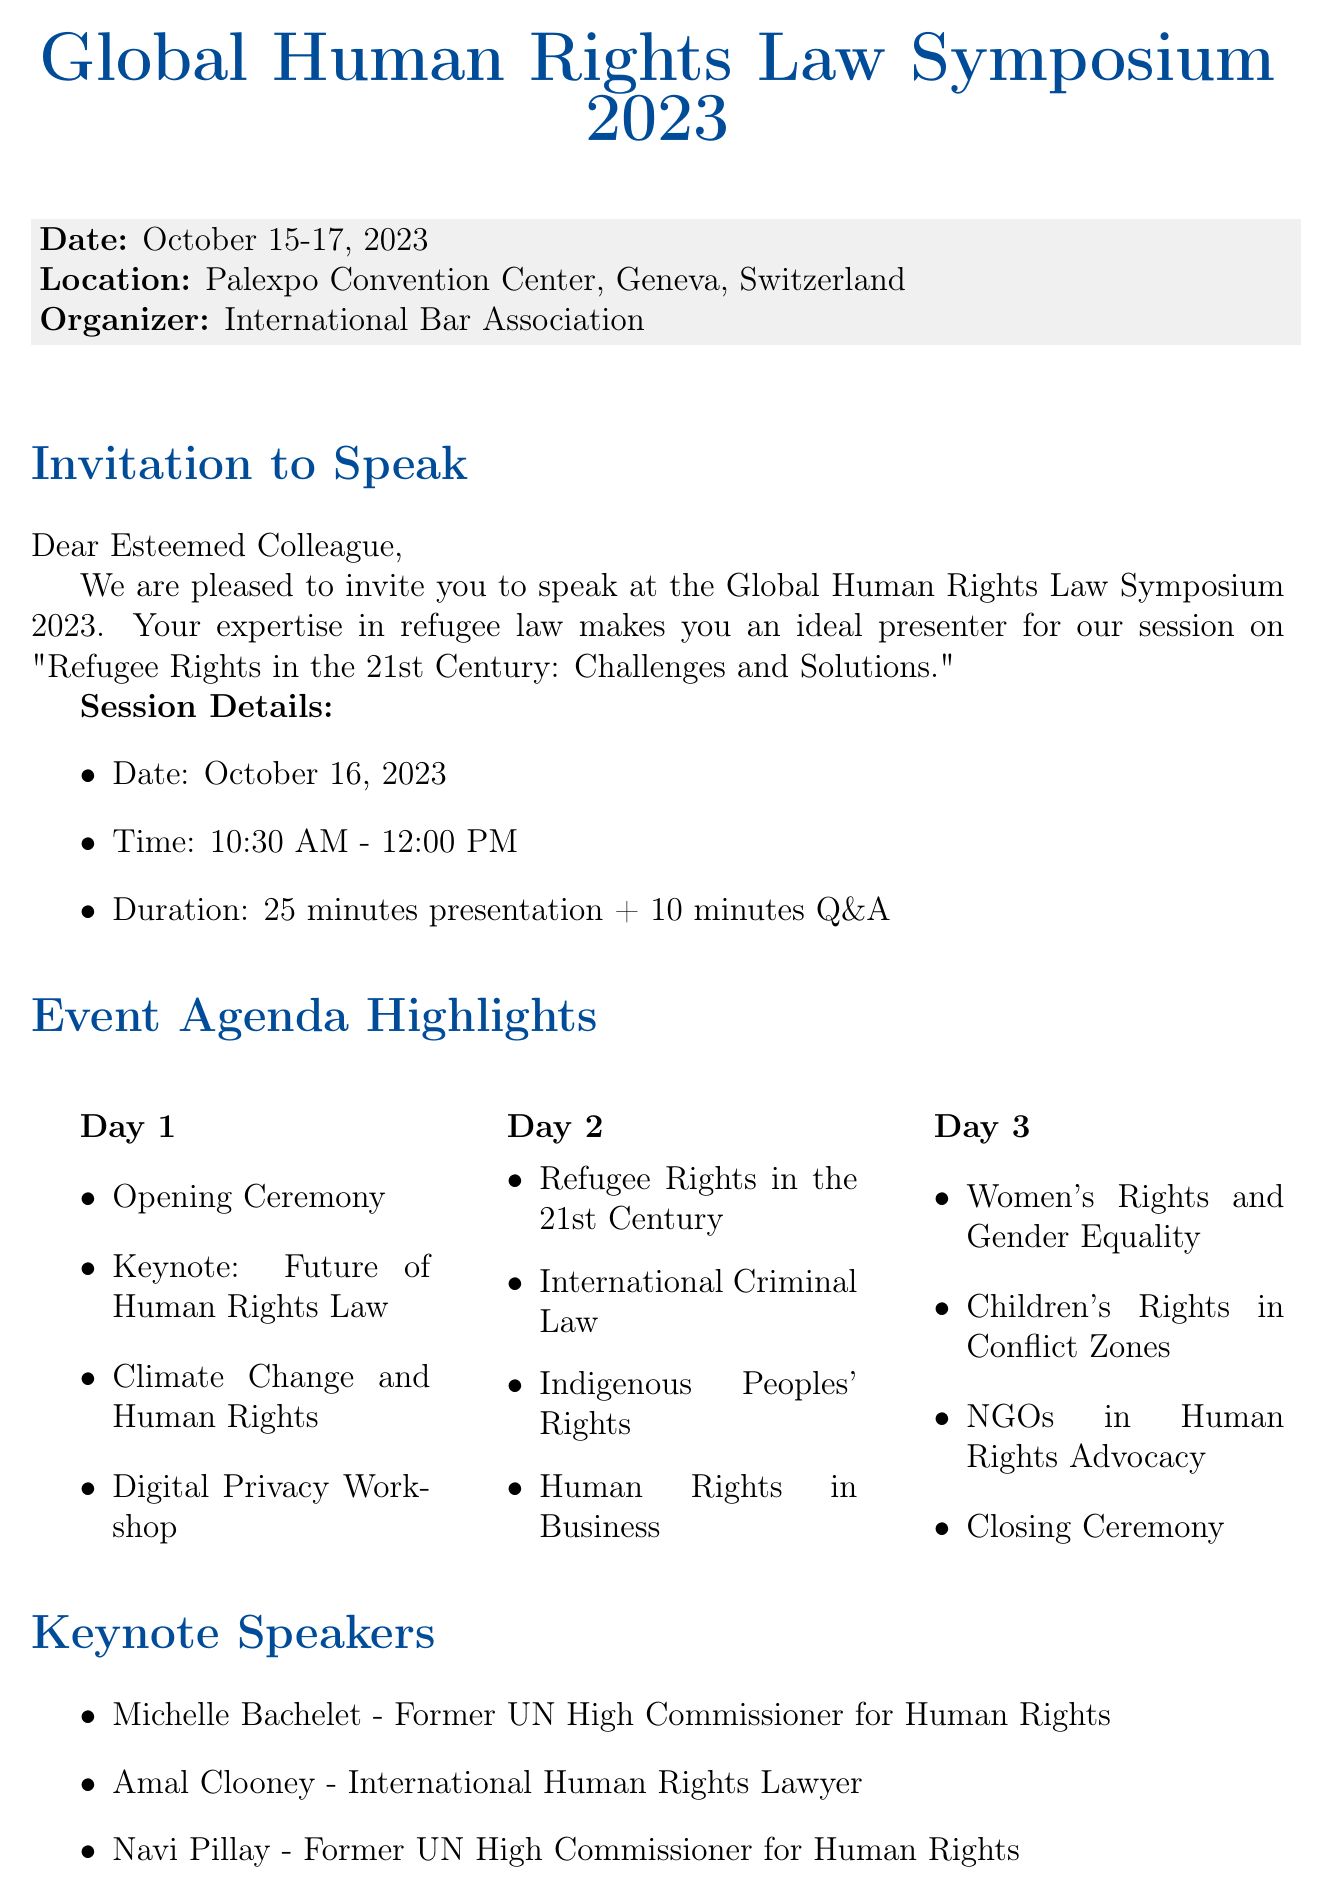What is the event name? The event name is specified in the document.
Answer: Global Human Rights Law Symposium 2023 Who is the organizer of the event? The organizer of the event is mentioned in the document.
Answer: International Bar Association When is the session on Refugee Rights scheduled? The date of the session is provided in the session details.
Answer: October 16, 2023 What is the expected audience of the conference? The expected audience includes different categories of professionals listed in the document.
Answer: Human rights lawyers and advocates How long is the speaking duration for the session? The speaking duration is detailed in the session information.
Answer: 25 minutes plus 10 minutes Q&A What are the dates of the event? The document lists the event dates explicitly.
Answer: October 15-17, 2023 What is one of the conference objectives? One of the objectives is specifically described in the objectives section.
Answer: Share best practices in human rights law Where is the venue located? The location of the venue is stated in the document.
Answer: Palexpo Convention Center, Geneva, Switzerland Who is one of the keynote speakers? The document lists several keynote speakers with their positions.
Answer: Michelle Bachelet 